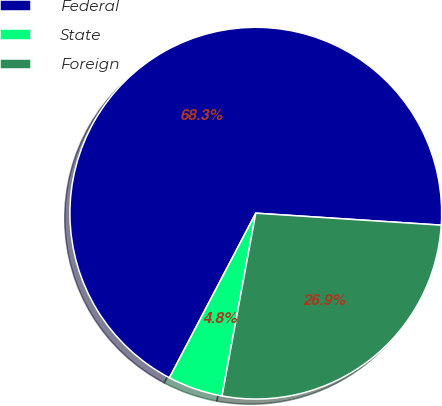Convert chart to OTSL. <chart><loc_0><loc_0><loc_500><loc_500><pie_chart><fcel>Federal<fcel>State<fcel>Foreign<nl><fcel>68.34%<fcel>4.78%<fcel>26.88%<nl></chart> 